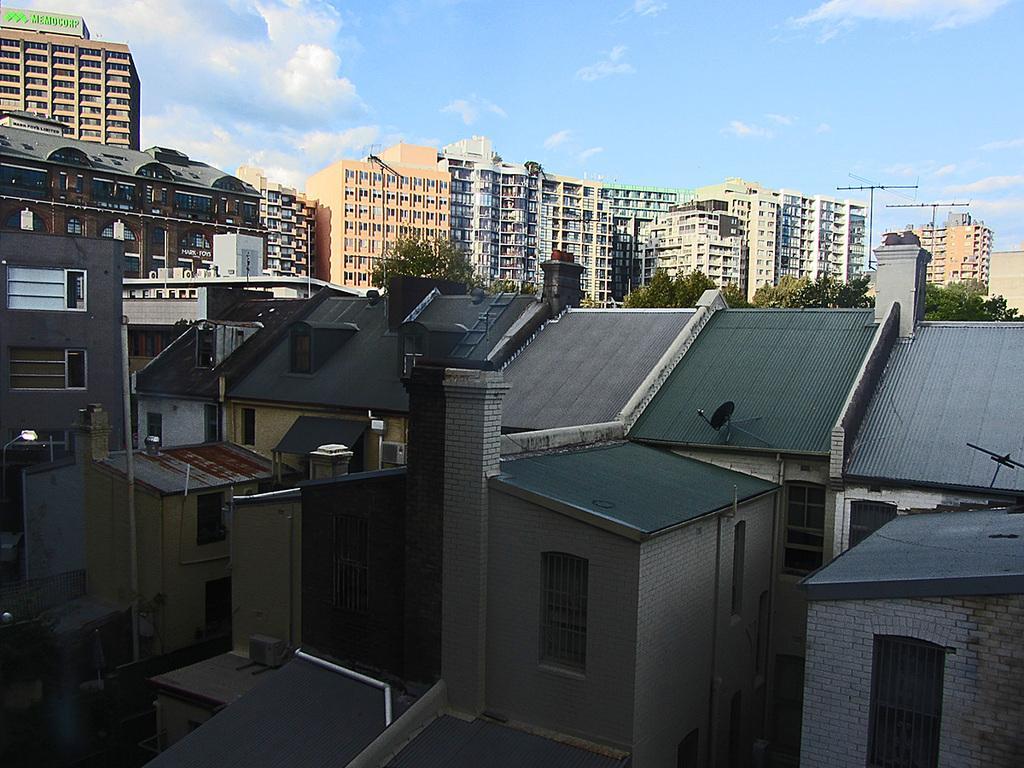Can you describe this image briefly? In this picture I see number of buildings and number of trees. In the background I see the sky. 